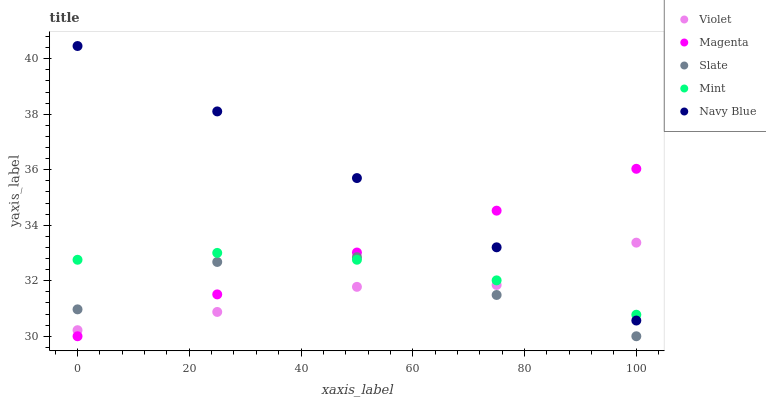Does Violet have the minimum area under the curve?
Answer yes or no. Yes. Does Navy Blue have the maximum area under the curve?
Answer yes or no. Yes. Does Magenta have the minimum area under the curve?
Answer yes or no. No. Does Magenta have the maximum area under the curve?
Answer yes or no. No. Is Magenta the smoothest?
Answer yes or no. Yes. Is Slate the roughest?
Answer yes or no. Yes. Is Mint the smoothest?
Answer yes or no. No. Is Mint the roughest?
Answer yes or no. No. Does Magenta have the lowest value?
Answer yes or no. Yes. Does Mint have the lowest value?
Answer yes or no. No. Does Navy Blue have the highest value?
Answer yes or no. Yes. Does Magenta have the highest value?
Answer yes or no. No. Is Slate less than Navy Blue?
Answer yes or no. Yes. Is Navy Blue greater than Slate?
Answer yes or no. Yes. Does Navy Blue intersect Magenta?
Answer yes or no. Yes. Is Navy Blue less than Magenta?
Answer yes or no. No. Is Navy Blue greater than Magenta?
Answer yes or no. No. Does Slate intersect Navy Blue?
Answer yes or no. No. 